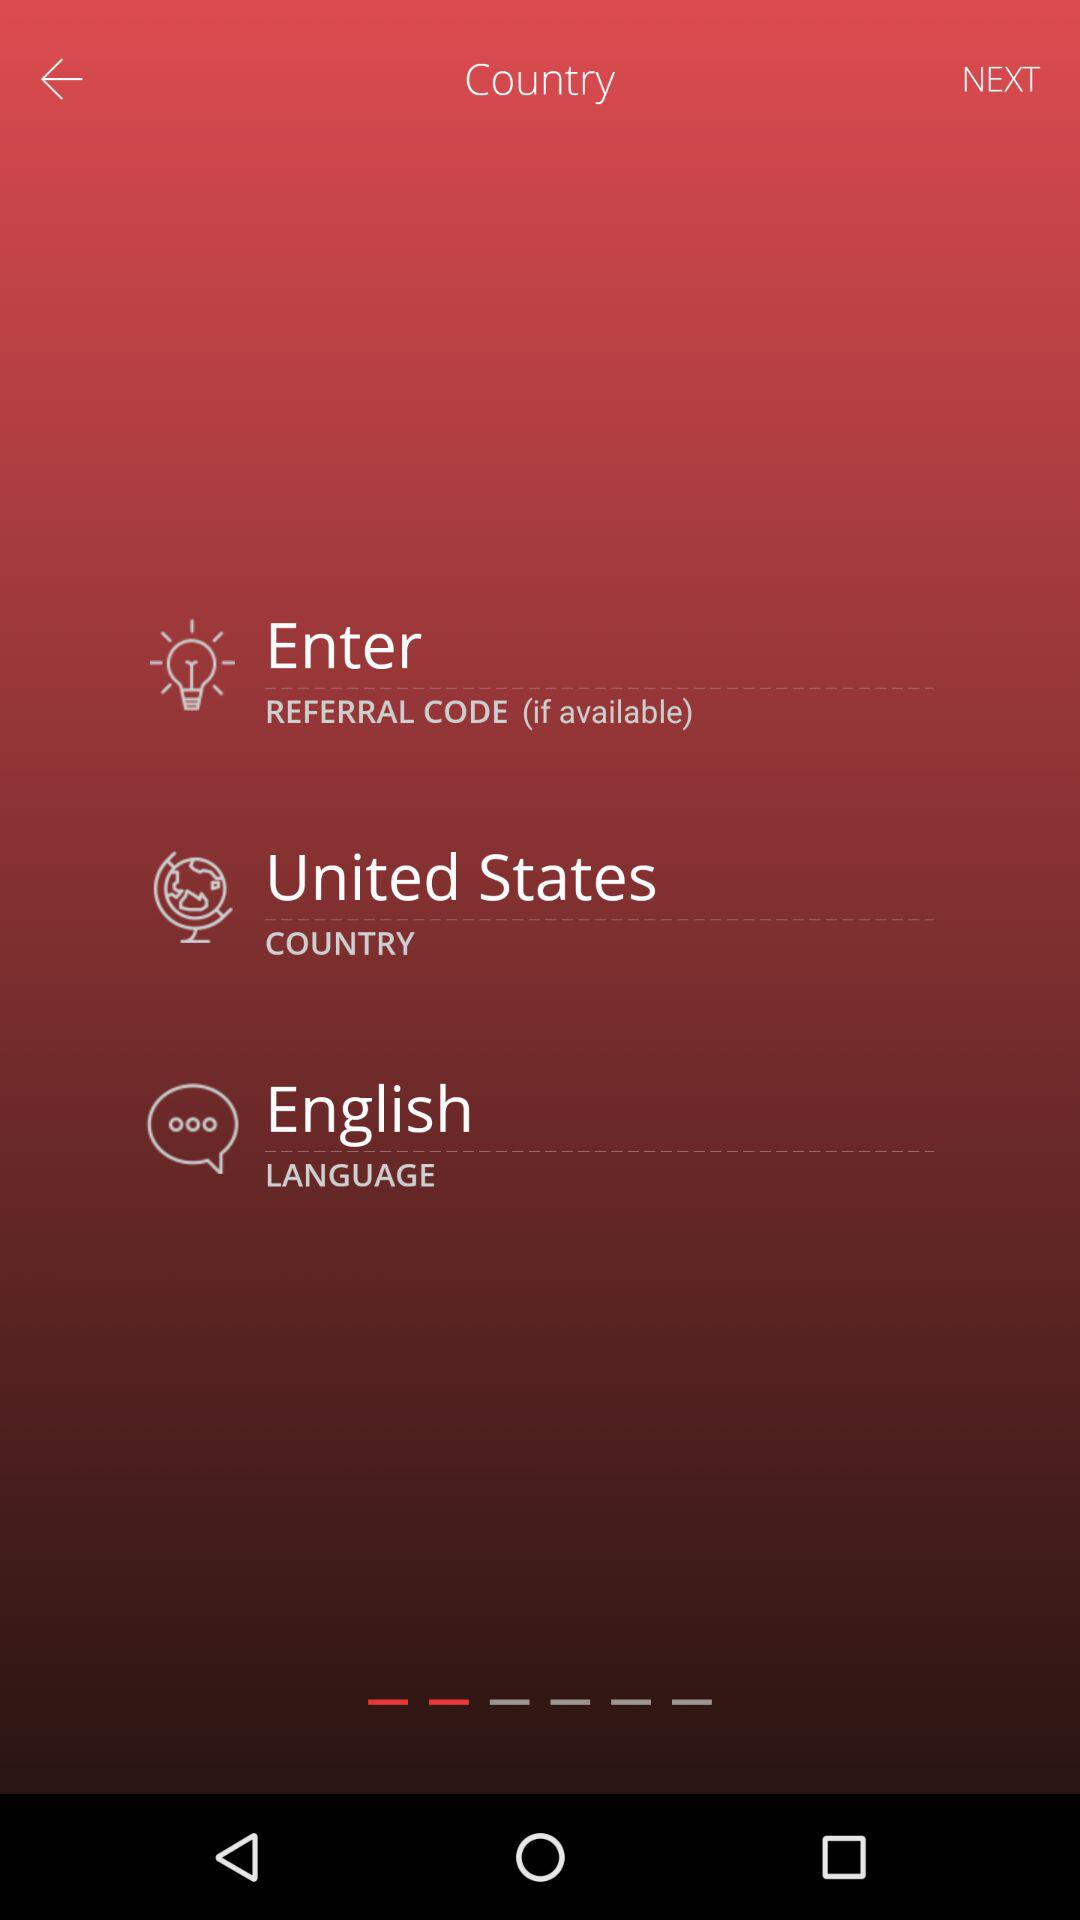What is the selected language? The selected language is English. 